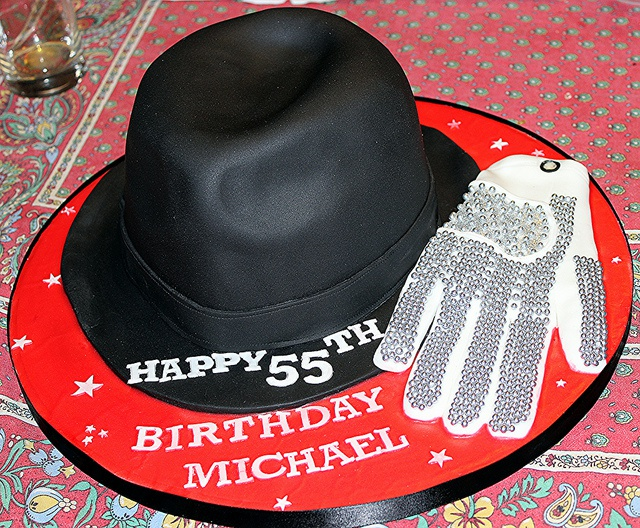Describe the objects in this image and their specific colors. I can see cake in brown, black, red, white, and gray tones, dining table in brown, salmon, darkgray, and lightgray tones, and cup in brown, gray, black, and maroon tones in this image. 